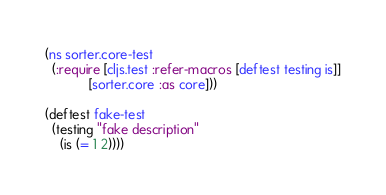Convert code to text. <code><loc_0><loc_0><loc_500><loc_500><_Clojure_>(ns sorter.core-test
  (:require [cljs.test :refer-macros [deftest testing is]]
            [sorter.core :as core]))

(deftest fake-test
  (testing "fake description"
    (is (= 1 2))))
</code> 